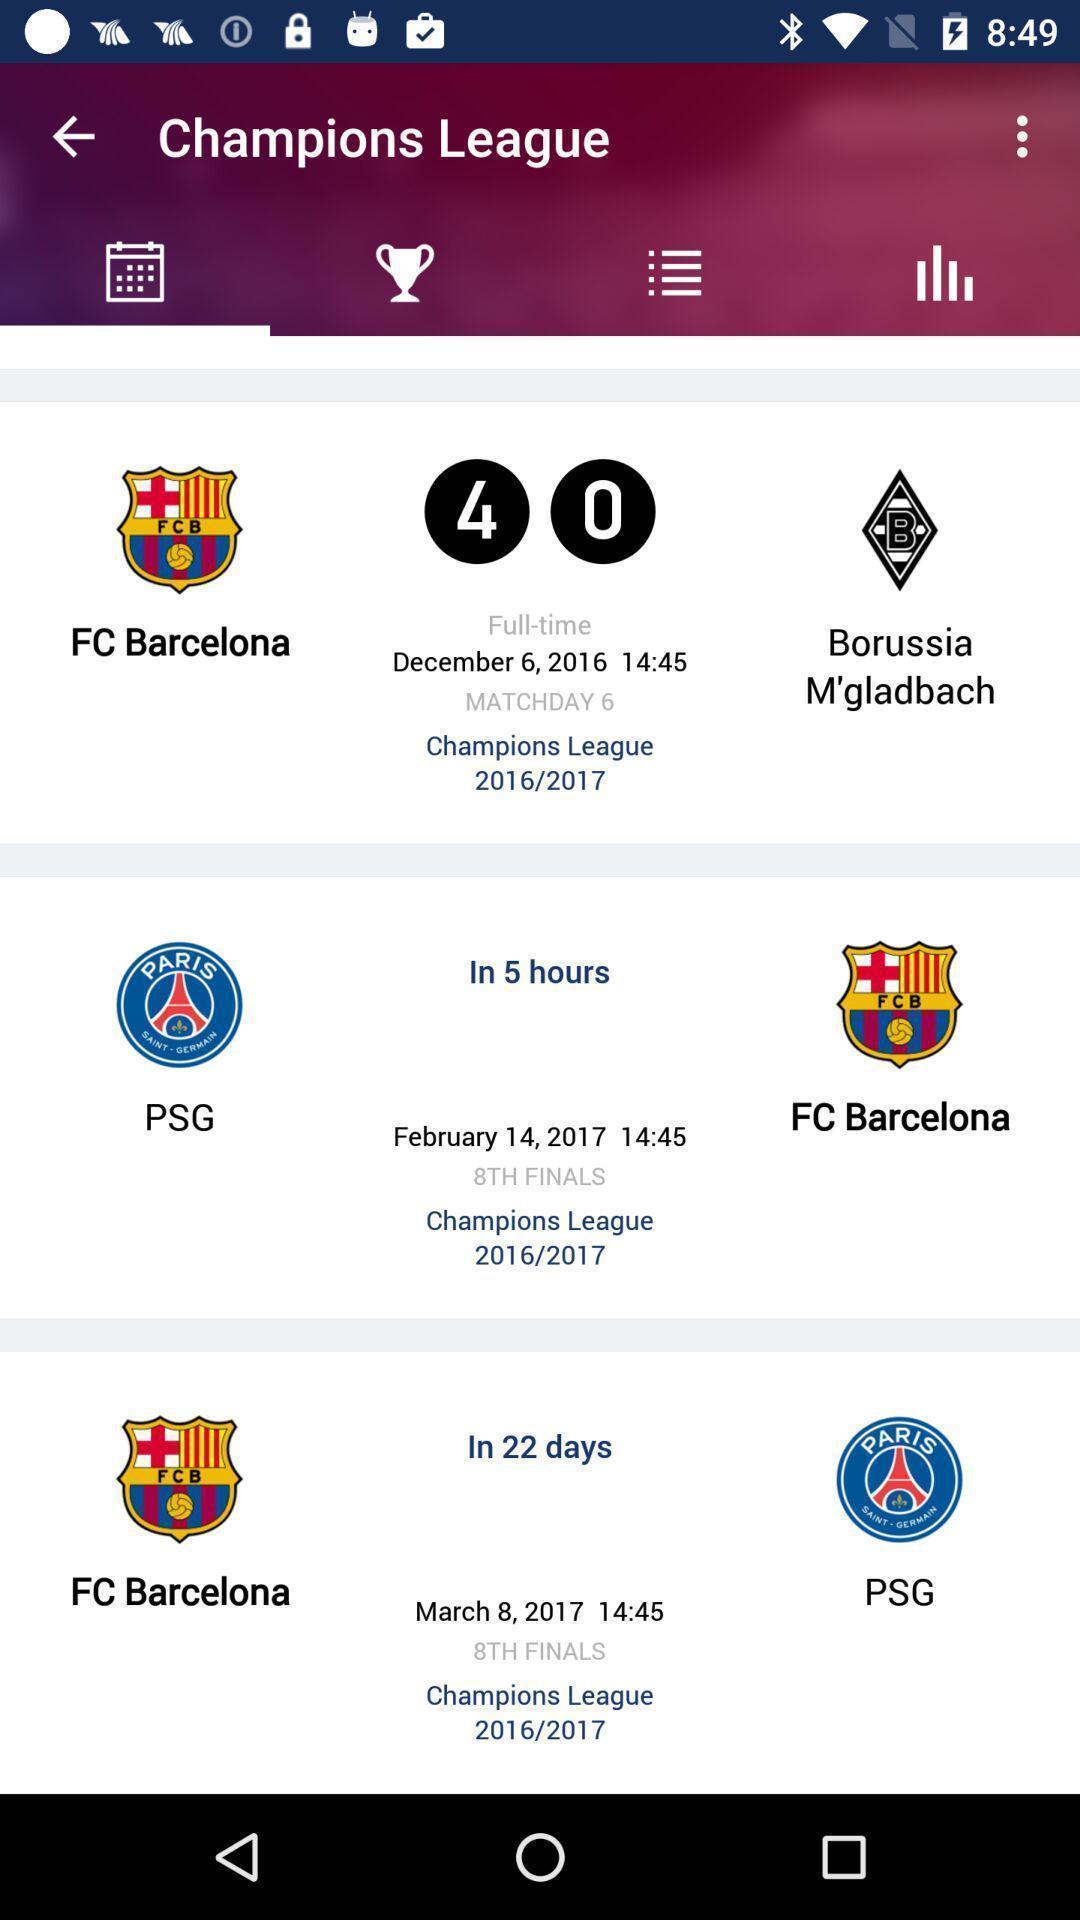Give me a narrative description of this picture. Page showing info in a sports related app. 